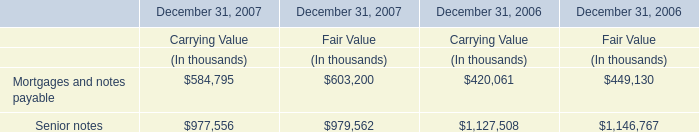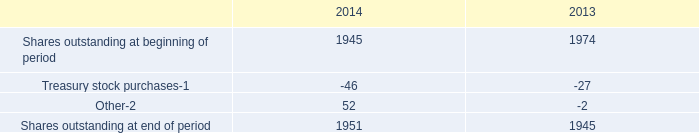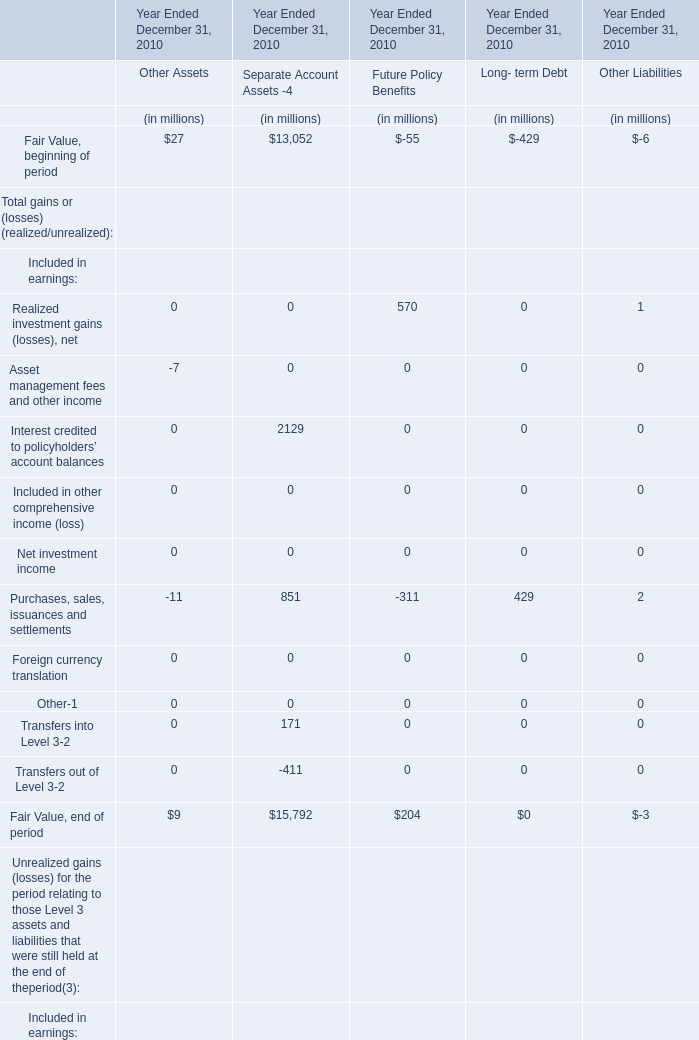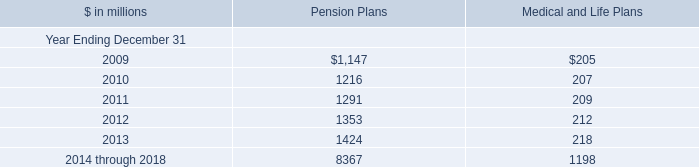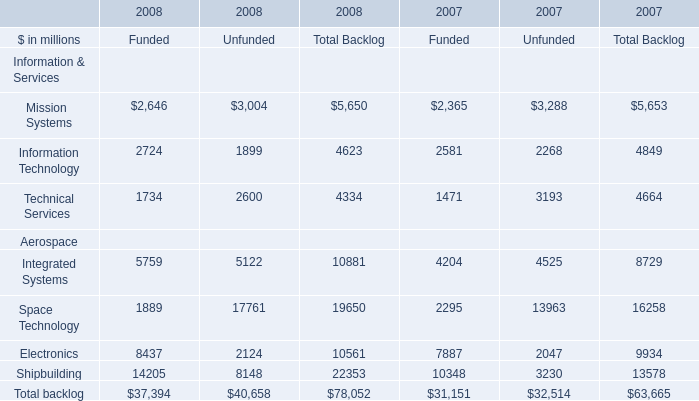What was the average of theIntegrated Systems in the years where Technical Services is positive? (in million) 
Computations: ((10881 + 8729) / 2)
Answer: 9805.0. 